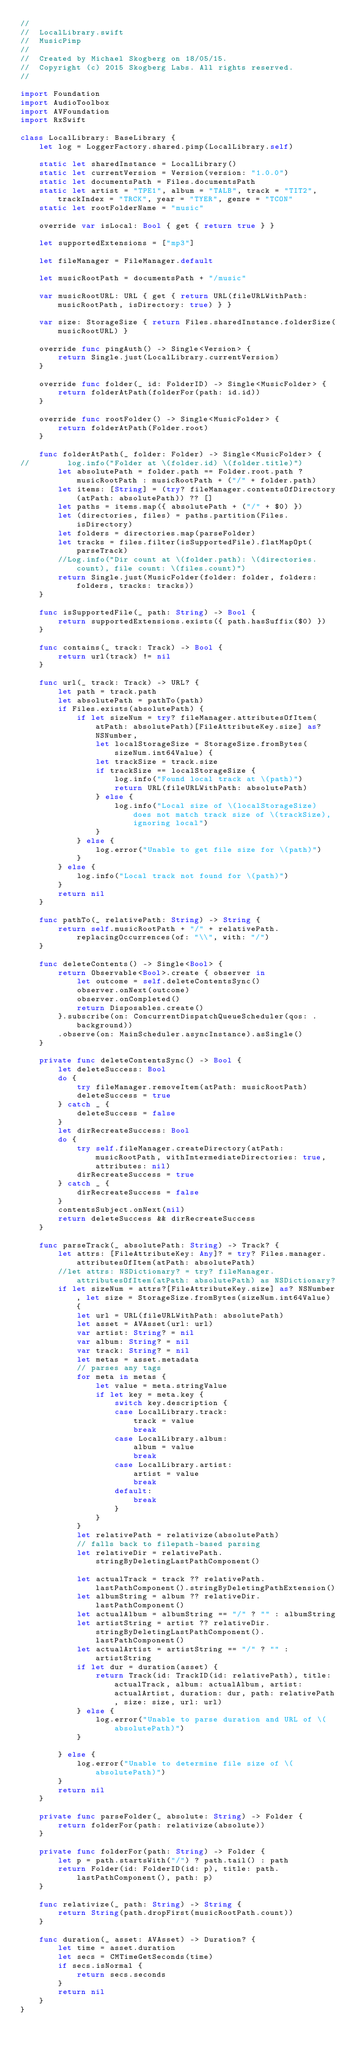<code> <loc_0><loc_0><loc_500><loc_500><_Swift_>//
//  LocalLibrary.swift
//  MusicPimp
//
//  Created by Michael Skogberg on 18/05/15.
//  Copyright (c) 2015 Skogberg Labs. All rights reserved.
//

import Foundation
import AudioToolbox
import AVFoundation
import RxSwift

class LocalLibrary: BaseLibrary {
    let log = LoggerFactory.shared.pimp(LocalLibrary.self)
    
    static let sharedInstance = LocalLibrary()
    static let currentVersion = Version(version: "1.0.0")
    static let documentsPath = Files.documentsPath
    static let artist = "TPE1", album = "TALB", track = "TIT2", trackIndex = "TRCK", year = "TYER", genre = "TCON"
    static let rootFolderName = "music"
    
    override var isLocal: Bool { get { return true } }
    
    let supportedExtensions = ["mp3"]
    
    let fileManager = FileManager.default
    
    let musicRootPath = documentsPath + "/music"

    var musicRootURL: URL { get { return URL(fileURLWithPath: musicRootPath, isDirectory: true) } }
    
    var size: StorageSize { return Files.sharedInstance.folderSize(musicRootURL) }
    
    override func pingAuth() -> Single<Version> {
        return Single.just(LocalLibrary.currentVersion)
    }
    
    override func folder(_ id: FolderID) -> Single<MusicFolder> {
        return folderAtPath(folderFor(path: id.id))
    }
    
    override func rootFolder() -> Single<MusicFolder> {
        return folderAtPath(Folder.root)
    }
    
    func folderAtPath(_ folder: Folder) -> Single<MusicFolder> {
//        log.info("Folder at \(folder.id) \(folder.title)")
        let absolutePath = folder.path == Folder.root.path ? musicRootPath : musicRootPath + ("/" + folder.path)
        let items: [String] = (try? fileManager.contentsOfDirectory(atPath: absolutePath)) ?? []
        let paths = items.map({ absolutePath + ("/" + $0) })
        let (directories, files) = paths.partition(Files.isDirectory)
        let folders = directories.map(parseFolder)
        let tracks = files.filter(isSupportedFile).flatMapOpt(parseTrack)
        //Log.info("Dir count at \(folder.path): \(directories.count), file count: \(files.count)")
        return Single.just(MusicFolder(folder: folder, folders: folders, tracks: tracks))
    }
    
    func isSupportedFile(_ path: String) -> Bool {
        return supportedExtensions.exists({ path.hasSuffix($0) })
    }
    
    func contains(_ track: Track) -> Bool {
        return url(track) != nil
    }
    
    func url(_ track: Track) -> URL? {
        let path = track.path
        let absolutePath = pathTo(path)
        if Files.exists(absolutePath) {
            if let sizeNum = try? fileManager.attributesOfItem(atPath: absolutePath)[FileAttributeKey.size] as? NSNumber,
                let localStorageSize = StorageSize.fromBytes(sizeNum.int64Value) {
                let trackSize = track.size
                if trackSize == localStorageSize {
                    log.info("Found local track at \(path)")
                    return URL(fileURLWithPath: absolutePath)
                } else {
                    log.info("Local size of \(localStorageSize) does not match track size of \(trackSize), ignoring local")
                }
            } else {
                log.error("Unable to get file size for \(path)")
            }
        } else {
            log.info("Local track not found for \(path)")
        }
        return nil
    }
    
    func pathTo(_ relativePath: String) -> String {
        return self.musicRootPath + "/" + relativePath.replacingOccurrences(of: "\\", with: "/")
    }
    
    func deleteContents() -> Single<Bool> {
        return Observable<Bool>.create { observer in
            let outcome = self.deleteContentsSync()
            observer.onNext(outcome)
            observer.onCompleted()
            return Disposables.create()
        }.subscribe(on: ConcurrentDispatchQueueScheduler(qos: .background))
        .observe(on: MainScheduler.asyncInstance).asSingle()
    }
    
    private func deleteContentsSync() -> Bool {
        let deleteSuccess: Bool
        do {
            try fileManager.removeItem(atPath: musicRootPath)
            deleteSuccess = true
        } catch _ {
            deleteSuccess = false
        }
        let dirRecreateSuccess: Bool
        do {
            try self.fileManager.createDirectory(atPath: musicRootPath, withIntermediateDirectories: true, attributes: nil)
            dirRecreateSuccess = true
        } catch _ {
            dirRecreateSuccess = false
        }
        contentsSubject.onNext(nil)
        return deleteSuccess && dirRecreateSuccess
    }
    
    func parseTrack(_ absolutePath: String) -> Track? {
        let attrs: [FileAttributeKey: Any]? = try? Files.manager.attributesOfItem(atPath: absolutePath)
        //let attrs: NSDictionary? = try? fileManager.attributesOfItem(atPath: absolutePath) as NSDictionary?
        if let sizeNum = attrs?[FileAttributeKey.size] as? NSNumber, let size = StorageSize.fromBytes(sizeNum.int64Value) {
            let url = URL(fileURLWithPath: absolutePath)
            let asset = AVAsset(url: url)
            var artist: String? = nil
            var album: String? = nil
            var track: String? = nil
            let metas = asset.metadata
            // parses any tags
            for meta in metas {
                let value = meta.stringValue
                if let key = meta.key {
                    switch key.description {
                    case LocalLibrary.track:
                        track = value
                        break
                    case LocalLibrary.album:
                        album = value
                        break
                    case LocalLibrary.artist:
                        artist = value
                        break
                    default:
                        break
                    }
                }
            }
            let relativePath = relativize(absolutePath)
            // falls back to filepath-based parsing
            let relativeDir = relativePath.stringByDeletingLastPathComponent()
                
            let actualTrack = track ?? relativePath.lastPathComponent().stringByDeletingPathExtension()
            let albumString = album ?? relativeDir.lastPathComponent()
            let actualAlbum = albumString == "/" ? "" : albumString
            let artistString = artist ?? relativeDir.stringByDeletingLastPathComponent().lastPathComponent()
            let actualArtist = artistString == "/" ? "" : artistString
            if let dur = duration(asset) {
                return Track(id: TrackID(id: relativePath), title: actualTrack, album: actualAlbum, artist: actualArtist, duration: dur, path: relativePath, size: size, url: url)
            } else {
                log.error("Unable to parse duration and URL of \(absolutePath)")
            }
            
        } else {
            log.error("Unable to determine file size of \(absolutePath)")
        }
        return nil
    }
    
    private func parseFolder(_ absolute: String) -> Folder {
        return folderFor(path: relativize(absolute))
    }
    
    private func folderFor(path: String) -> Folder {
        let p = path.startsWith("/") ? path.tail() : path
        return Folder(id: FolderID(id: p), title: path.lastPathComponent(), path: p)
    }
    
    func relativize(_ path: String) -> String {
        return String(path.dropFirst(musicRootPath.count))
    }
    
    func duration(_ asset: AVAsset) -> Duration? {
        let time = asset.duration
        let secs = CMTimeGetSeconds(time)
        if secs.isNormal {
            return secs.seconds
        }
        return nil
    }
}
</code> 